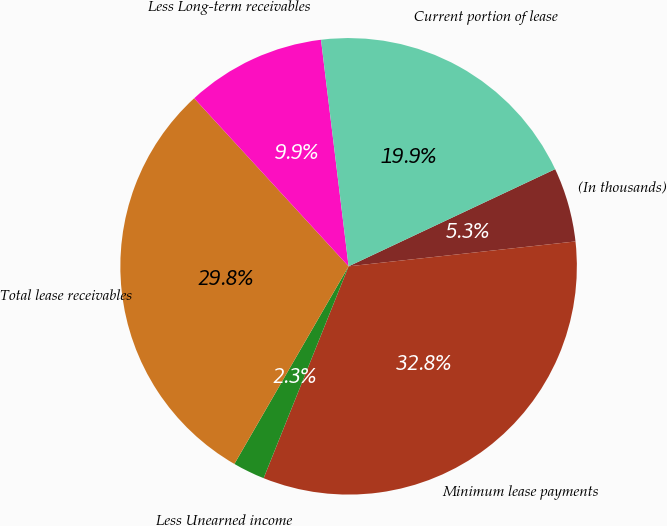Convert chart to OTSL. <chart><loc_0><loc_0><loc_500><loc_500><pie_chart><fcel>(In thousands)<fcel>Minimum lease payments<fcel>Less Unearned income<fcel>Total lease receivables<fcel>Less Long-term receivables<fcel>Current portion of lease<nl><fcel>5.26%<fcel>32.81%<fcel>2.27%<fcel>29.83%<fcel>9.9%<fcel>19.93%<nl></chart> 